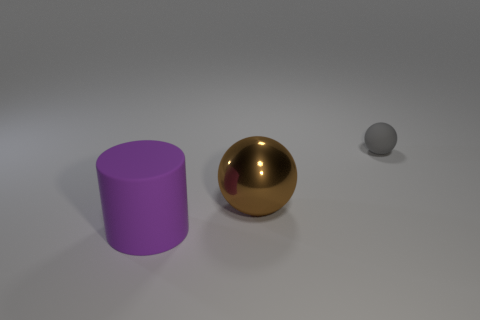How do the sizes of these objects compare? From the image, the golden sphere is the largest object, followed by the violet cylinder which is taller, but its diameter appears to be smaller than the sphere's circumference. The tiny grey sphere is the smallest object by a significant margin. 